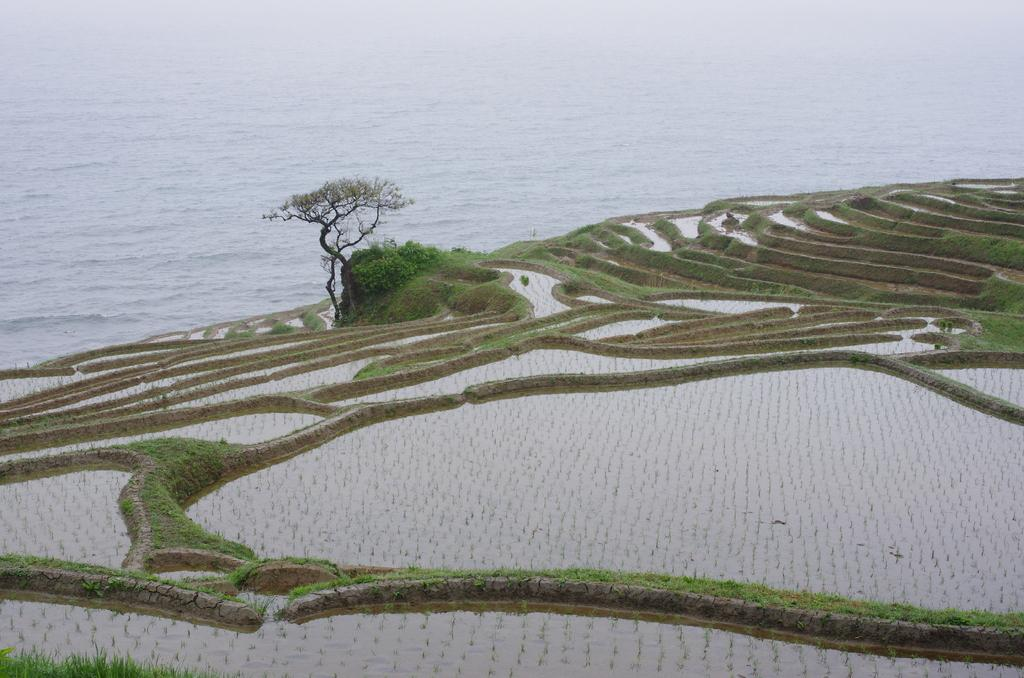What type of plants can be seen in the image? There are crops with water in the image. What is located in the middle of the image? There is a tree in the middle of the image. Can you describe the presence of water in the image? Yes, there is water visible in the image. What type of pin can be seen holding the tree in place in the image? There is no pin present in the image, and the tree is not held in place. 